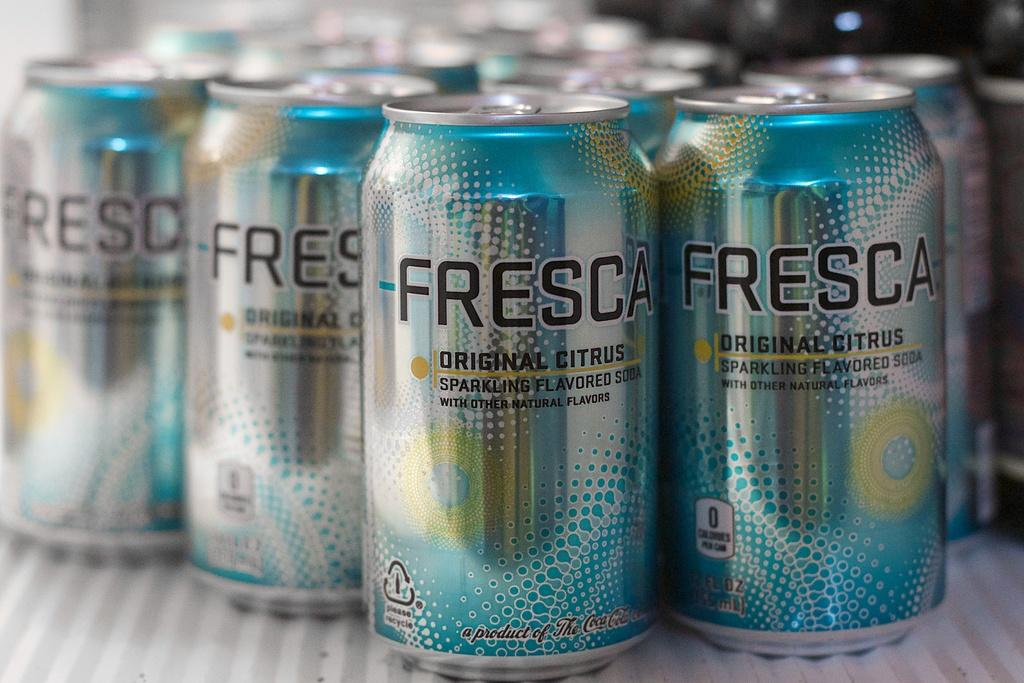<image>
Relay a brief, clear account of the picture shown. Cans of Fresca soda are arranged on a white surface. 